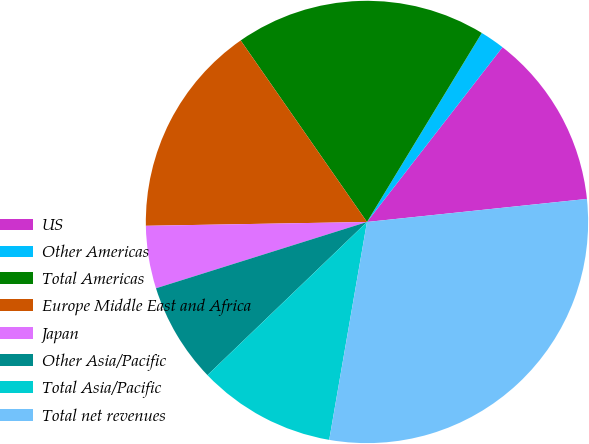<chart> <loc_0><loc_0><loc_500><loc_500><pie_chart><fcel>US<fcel>Other Americas<fcel>Total Americas<fcel>Europe Middle East and Africa<fcel>Japan<fcel>Other Asia/Pacific<fcel>Total Asia/Pacific<fcel>Total net revenues<nl><fcel>12.84%<fcel>1.81%<fcel>18.36%<fcel>15.6%<fcel>4.57%<fcel>7.33%<fcel>10.09%<fcel>29.39%<nl></chart> 